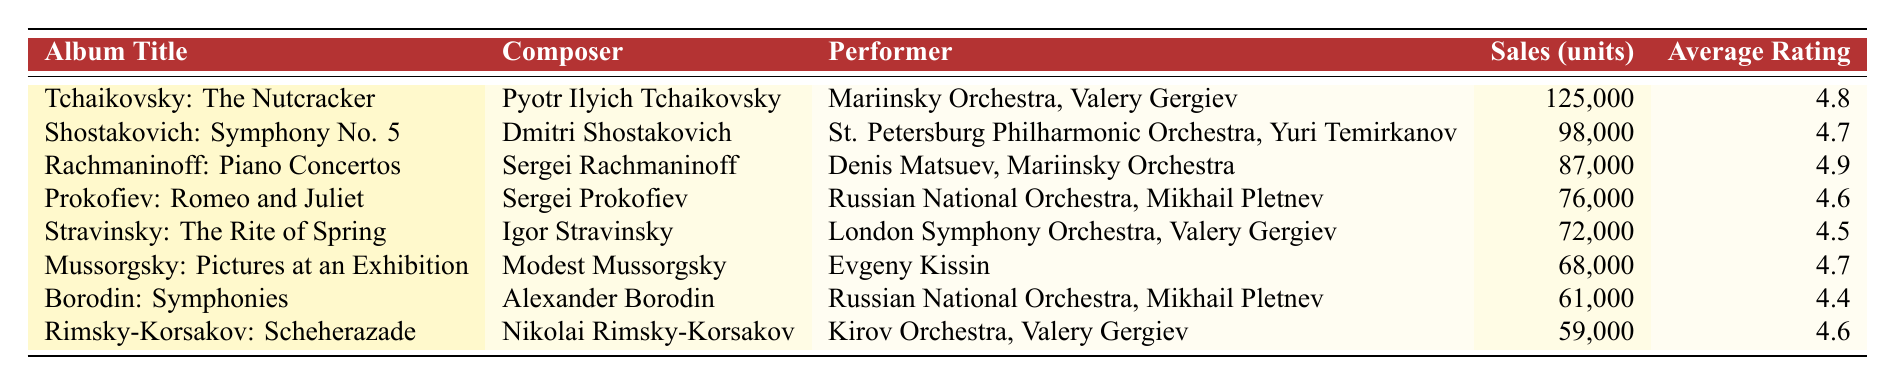What is the album title with the highest sales units? The table lists the sales units for each album, and "Tchaikovsky: The Nutcracker" has the highest sales at 125,000 units.
Answer: Tchaikovsky: The Nutcracker How many units did "Rachmaninoff: Piano Concertos" sell? The table provides a direct entry for "Rachmaninoff: Piano Concertos," showing it sold 87,000 units.
Answer: 87,000 Is the average rating of "Prokofiev: Romeo and Juliet" greater than 4.5? According to the table, "Prokofiev: Romeo and Juliet" has an average rating of 4.6, which is indeed greater than 4.5.
Answer: Yes What are the total sales of the top three albums? The top three albums based on sales are "Tchaikovsky: The Nutcracker" (125,000), "Shostakovich: Symphony No. 5" (98,000), and "Rachmaninoff: Piano Concertos" (87,000). Summing them gives: 125,000 + 98,000 + 87,000 = 310,000.
Answer: 310,000 Which composer has the highest-rated album? To determine this, we review the average ratings for each album. "Rachmaninoff: Piano Concertos" has the highest rating of 4.9 among all listed albums, making Sergei Rachmaninoff the composer of the highest-rated album.
Answer: Sergei Rachmaninoff Are there any albums with a rating of 4.8 or higher other than "Tchaikovsky: The Nutcracker"? The table shows the average ratings. "Rachmaninoff: Piano Concertos" (4.9) and "Shostakovich: Symphony No. 5" (4.7) also meet the criteria, so the answer would exclude "Tchaikovsky: The Nutcracker."
Answer: Yes What is the difference in sales between "Stravinsky: The Rite of Spring" and "Rimsky-Korsakov: Scheherazade"? The sales for "Stravinsky: The Rite of Spring" is 72,000 and for "Rimsky-Korsakov: Scheherazade" is 59,000. The difference is calculated by subtracting the latter from the former: 72,000 - 59,000 = 13,000.
Answer: 13,000 Which performer has the album with the lowest sales? "Rimsky-Korsakov: Scheherazade" performed by Kirov Orchestra, Valery Gergiev has the lowest sales with only 59,000 units sold, making it the answer to this question.
Answer: Kirov Orchestra, Valery Gergiev What is the average rating of albums that sold more than 70,000 units? The albums with sales greater than 70,000 units are "Tchaikovsky: The Nutcracker" (4.8), "Shostakovich: Symphony No. 5" (4.7), "Rachmaninoff: Piano Concertos" (4.9), "Prokofiev: Romeo and Juliet" (4.6), and "Stravinsky: The Rite of Spring" (4.5). Their average rating is calculated as (4.8 + 4.7 + 4.9 + 4.6 + 4.5) / 5 = 4.7.
Answer: 4.7 